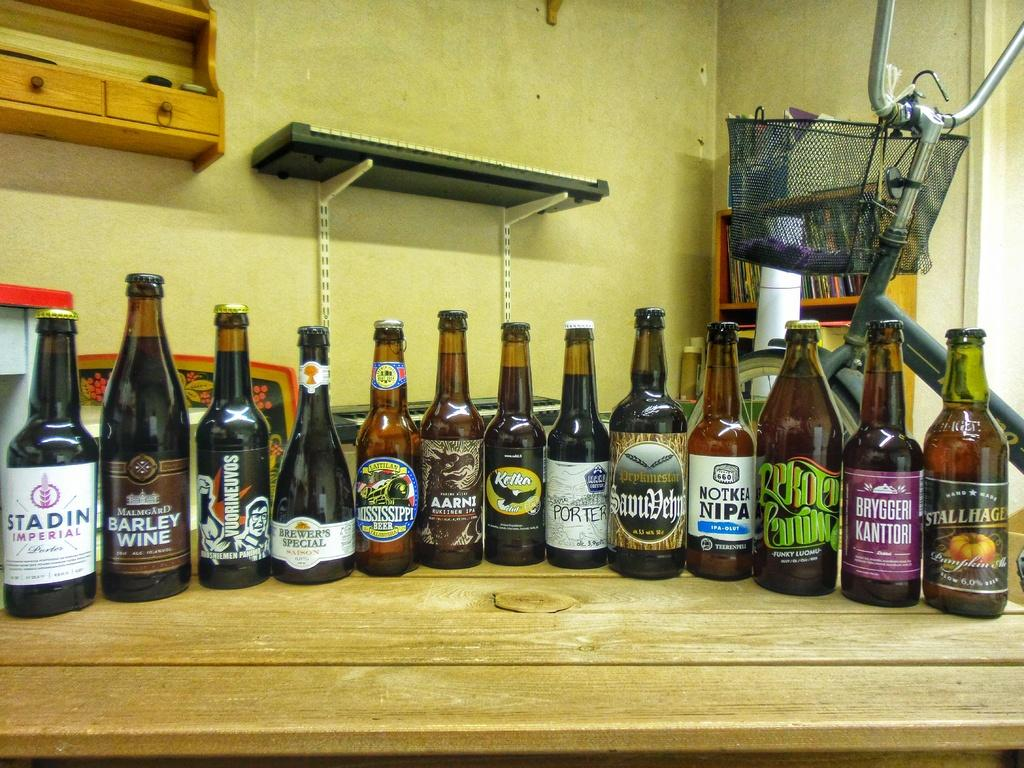<image>
Render a clear and concise summary of the photo. the word Porter is on the front of a beer bottle 